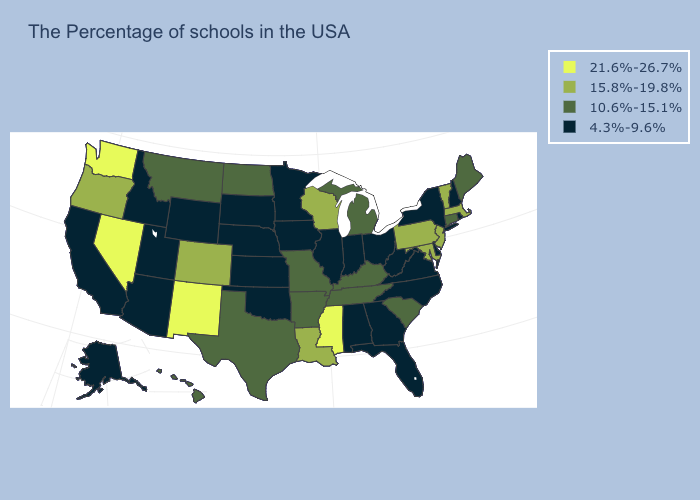How many symbols are there in the legend?
Write a very short answer. 4. What is the value of South Dakota?
Keep it brief. 4.3%-9.6%. Does the map have missing data?
Write a very short answer. No. Name the states that have a value in the range 21.6%-26.7%?
Short answer required. Mississippi, New Mexico, Nevada, Washington. What is the value of Alaska?
Keep it brief. 4.3%-9.6%. What is the highest value in the MidWest ?
Keep it brief. 15.8%-19.8%. Does the first symbol in the legend represent the smallest category?
Concise answer only. No. Does the map have missing data?
Give a very brief answer. No. Does Rhode Island have the same value as Mississippi?
Answer briefly. No. Among the states that border Virginia , which have the lowest value?
Be succinct. North Carolina, West Virginia. Name the states that have a value in the range 15.8%-19.8%?
Give a very brief answer. Massachusetts, Vermont, New Jersey, Maryland, Pennsylvania, Wisconsin, Louisiana, Colorado, Oregon. Name the states that have a value in the range 15.8%-19.8%?
Keep it brief. Massachusetts, Vermont, New Jersey, Maryland, Pennsylvania, Wisconsin, Louisiana, Colorado, Oregon. Does the map have missing data?
Write a very short answer. No. What is the value of Arizona?
Concise answer only. 4.3%-9.6%. Among the states that border Georgia , which have the highest value?
Quick response, please. South Carolina, Tennessee. 